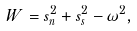Convert formula to latex. <formula><loc_0><loc_0><loc_500><loc_500>W = s ^ { 2 } _ { n } + s ^ { 2 } _ { s } - \omega ^ { 2 } ,</formula> 